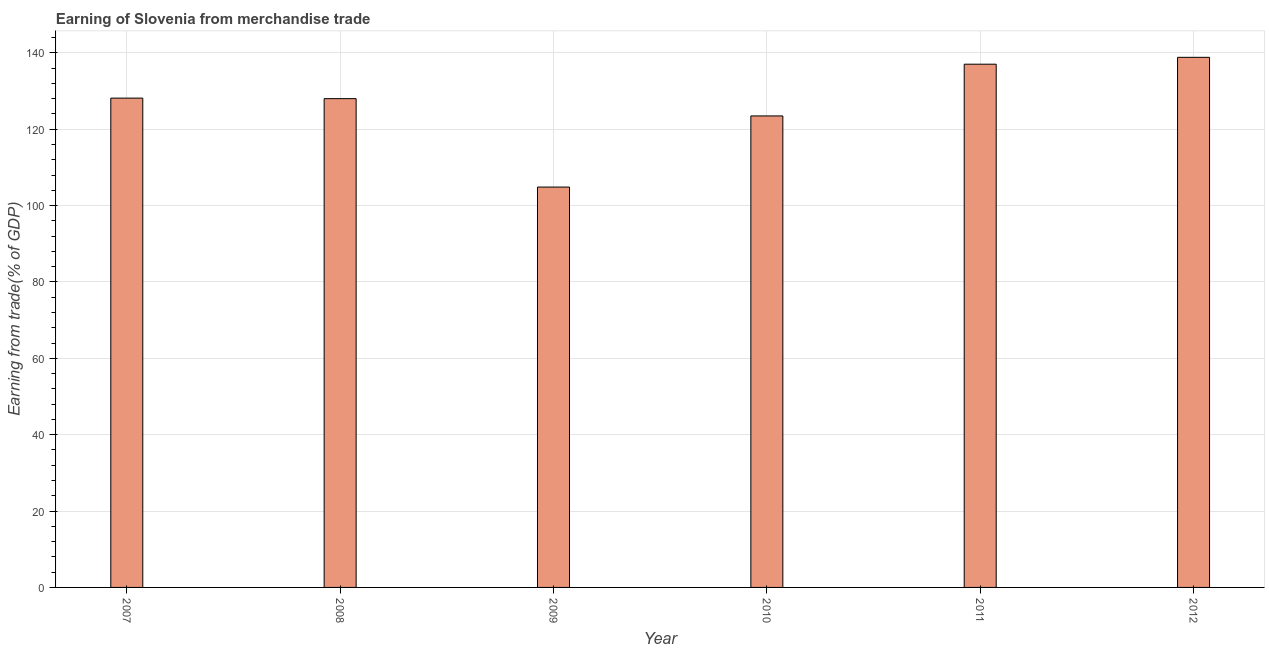Does the graph contain any zero values?
Provide a succinct answer. No. Does the graph contain grids?
Your answer should be very brief. Yes. What is the title of the graph?
Give a very brief answer. Earning of Slovenia from merchandise trade. What is the label or title of the Y-axis?
Keep it short and to the point. Earning from trade(% of GDP). What is the earning from merchandise trade in 2009?
Your answer should be very brief. 104.86. Across all years, what is the maximum earning from merchandise trade?
Your response must be concise. 138.84. Across all years, what is the minimum earning from merchandise trade?
Your answer should be very brief. 104.86. In which year was the earning from merchandise trade minimum?
Provide a succinct answer. 2009. What is the sum of the earning from merchandise trade?
Your answer should be compact. 760.38. What is the difference between the earning from merchandise trade in 2007 and 2012?
Provide a succinct answer. -10.68. What is the average earning from merchandise trade per year?
Keep it short and to the point. 126.73. What is the median earning from merchandise trade?
Offer a very short reply. 128.08. What is the ratio of the earning from merchandise trade in 2008 to that in 2009?
Give a very brief answer. 1.22. Is the difference between the earning from merchandise trade in 2007 and 2011 greater than the difference between any two years?
Give a very brief answer. No. What is the difference between the highest and the second highest earning from merchandise trade?
Keep it short and to the point. 1.8. Is the sum of the earning from merchandise trade in 2009 and 2010 greater than the maximum earning from merchandise trade across all years?
Ensure brevity in your answer.  Yes. What is the difference between the highest and the lowest earning from merchandise trade?
Offer a terse response. 33.98. In how many years, is the earning from merchandise trade greater than the average earning from merchandise trade taken over all years?
Offer a very short reply. 4. How many bars are there?
Give a very brief answer. 6. Are all the bars in the graph horizontal?
Make the answer very short. No. How many years are there in the graph?
Provide a short and direct response. 6. What is the difference between two consecutive major ticks on the Y-axis?
Ensure brevity in your answer.  20. What is the Earning from trade(% of GDP) in 2007?
Make the answer very short. 128.15. What is the Earning from trade(% of GDP) of 2008?
Give a very brief answer. 128.01. What is the Earning from trade(% of GDP) of 2009?
Your response must be concise. 104.86. What is the Earning from trade(% of GDP) in 2010?
Your answer should be very brief. 123.49. What is the Earning from trade(% of GDP) in 2011?
Ensure brevity in your answer.  137.04. What is the Earning from trade(% of GDP) in 2012?
Your response must be concise. 138.84. What is the difference between the Earning from trade(% of GDP) in 2007 and 2008?
Your answer should be very brief. 0.14. What is the difference between the Earning from trade(% of GDP) in 2007 and 2009?
Give a very brief answer. 23.3. What is the difference between the Earning from trade(% of GDP) in 2007 and 2010?
Ensure brevity in your answer.  4.67. What is the difference between the Earning from trade(% of GDP) in 2007 and 2011?
Offer a very short reply. -8.88. What is the difference between the Earning from trade(% of GDP) in 2007 and 2012?
Your answer should be compact. -10.68. What is the difference between the Earning from trade(% of GDP) in 2008 and 2009?
Give a very brief answer. 23.16. What is the difference between the Earning from trade(% of GDP) in 2008 and 2010?
Make the answer very short. 4.53. What is the difference between the Earning from trade(% of GDP) in 2008 and 2011?
Your answer should be very brief. -9.02. What is the difference between the Earning from trade(% of GDP) in 2008 and 2012?
Provide a succinct answer. -10.82. What is the difference between the Earning from trade(% of GDP) in 2009 and 2010?
Give a very brief answer. -18.63. What is the difference between the Earning from trade(% of GDP) in 2009 and 2011?
Make the answer very short. -32.18. What is the difference between the Earning from trade(% of GDP) in 2009 and 2012?
Provide a short and direct response. -33.98. What is the difference between the Earning from trade(% of GDP) in 2010 and 2011?
Make the answer very short. -13.55. What is the difference between the Earning from trade(% of GDP) in 2010 and 2012?
Offer a very short reply. -15.35. What is the difference between the Earning from trade(% of GDP) in 2011 and 2012?
Provide a short and direct response. -1.8. What is the ratio of the Earning from trade(% of GDP) in 2007 to that in 2008?
Your answer should be very brief. 1. What is the ratio of the Earning from trade(% of GDP) in 2007 to that in 2009?
Make the answer very short. 1.22. What is the ratio of the Earning from trade(% of GDP) in 2007 to that in 2010?
Your response must be concise. 1.04. What is the ratio of the Earning from trade(% of GDP) in 2007 to that in 2011?
Your answer should be very brief. 0.94. What is the ratio of the Earning from trade(% of GDP) in 2007 to that in 2012?
Offer a terse response. 0.92. What is the ratio of the Earning from trade(% of GDP) in 2008 to that in 2009?
Provide a short and direct response. 1.22. What is the ratio of the Earning from trade(% of GDP) in 2008 to that in 2011?
Provide a short and direct response. 0.93. What is the ratio of the Earning from trade(% of GDP) in 2008 to that in 2012?
Your answer should be compact. 0.92. What is the ratio of the Earning from trade(% of GDP) in 2009 to that in 2010?
Ensure brevity in your answer.  0.85. What is the ratio of the Earning from trade(% of GDP) in 2009 to that in 2011?
Make the answer very short. 0.77. What is the ratio of the Earning from trade(% of GDP) in 2009 to that in 2012?
Ensure brevity in your answer.  0.76. What is the ratio of the Earning from trade(% of GDP) in 2010 to that in 2011?
Your answer should be compact. 0.9. What is the ratio of the Earning from trade(% of GDP) in 2010 to that in 2012?
Make the answer very short. 0.89. 